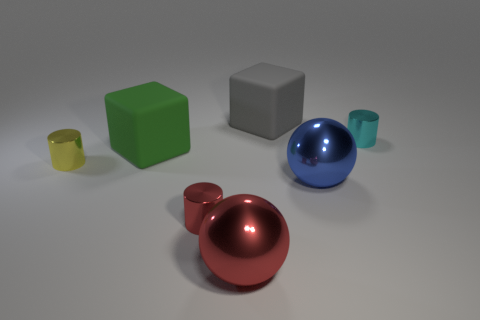Subtract all tiny red metallic cylinders. How many cylinders are left? 2 Subtract all cubes. How many objects are left? 5 Add 1 big green matte cylinders. How many objects exist? 8 Subtract all green cylinders. Subtract all blue spheres. How many cylinders are left? 3 Subtract 0 blue cylinders. How many objects are left? 7 Subtract all large blue things. Subtract all gray rubber objects. How many objects are left? 5 Add 6 yellow shiny cylinders. How many yellow shiny cylinders are left? 7 Add 6 blue things. How many blue things exist? 7 